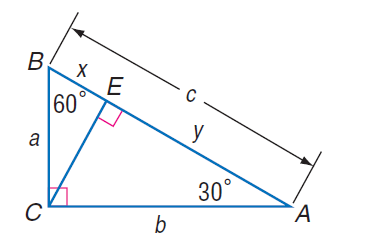Question: If x = 7 \sqrt { 3 }, find y.
Choices:
A. 7
B. 7 \sqrt { 3 }
C. 21 \sqrt { 3 }
D. 63
Answer with the letter. Answer: C Question: If a = 10 \sqrt { 3 }, find C E.
Choices:
A. 5 \sqrt 3
B. 10
C. 15
D. 10 \sqrt 3
Answer with the letter. Answer: C Question: If a = 10 \sqrt { 3 }, find y.
Choices:
A. 10
B. 15
C. 10 \sqrt { 3 }
D. 15 \sqrt { 3 }
Answer with the letter. Answer: D Question: If x = 7 \sqrt { 3 }, find a.
Choices:
A. 7
B. 12 \sqrt { 3 }
C. 14 \sqrt { 3 }
D. 16 \sqrt { 3 }
Answer with the letter. Answer: C Question: If x = 7 \sqrt { 3 }, find C E.
Choices:
A. 7
B. 14
C. 21
D. 14 \sqrt { 3 }
Answer with the letter. Answer: C Question: If x = 7 \sqrt { 3 }, find b.
Choices:
A. 7
B. 7 \sqrt { 3 }
C. 14 \sqrt { 3 }
D. 42
Answer with the letter. Answer: D 